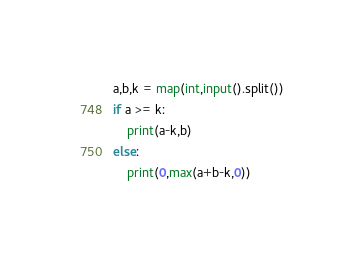Convert code to text. <code><loc_0><loc_0><loc_500><loc_500><_Python_>a,b,k = map(int,input().split())
if a >= k:
    print(a-k,b)
else:
    print(0,max(a+b-k,0))</code> 